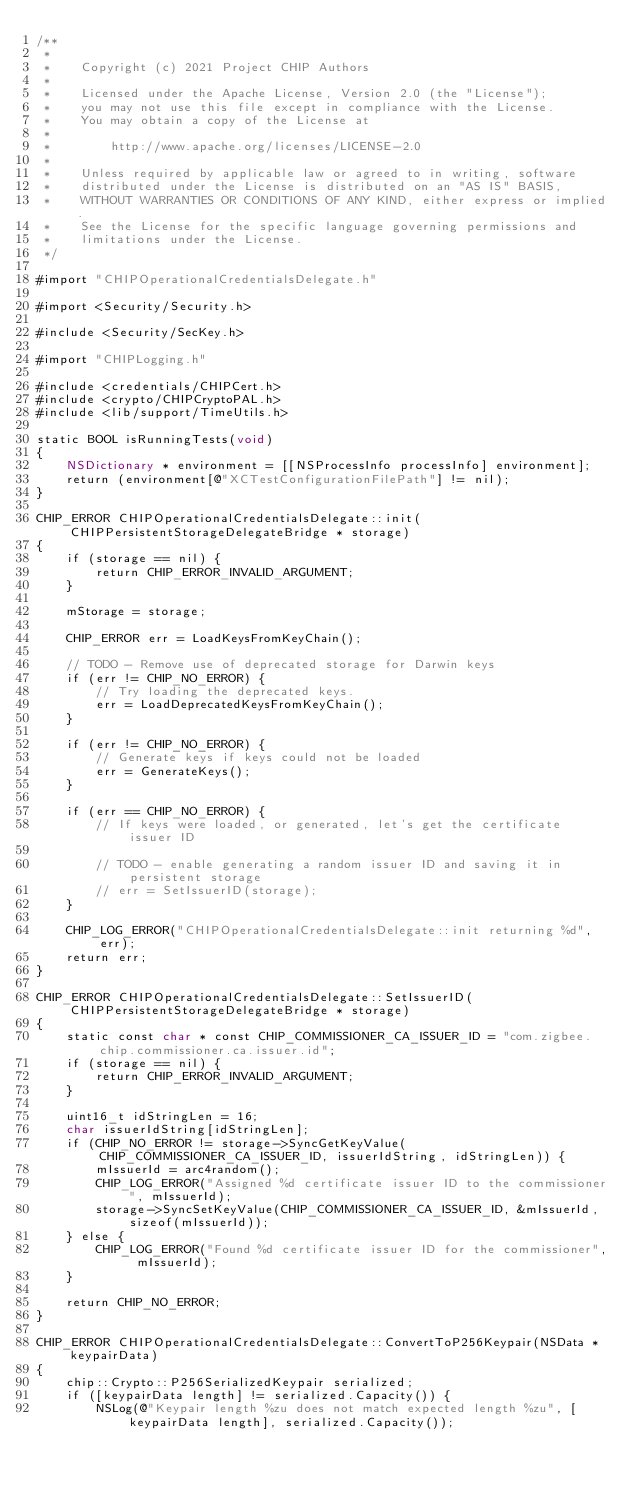Convert code to text. <code><loc_0><loc_0><loc_500><loc_500><_ObjectiveC_>/**
 *
 *    Copyright (c) 2021 Project CHIP Authors
 *
 *    Licensed under the Apache License, Version 2.0 (the "License");
 *    you may not use this file except in compliance with the License.
 *    You may obtain a copy of the License at
 *
 *        http://www.apache.org/licenses/LICENSE-2.0
 *
 *    Unless required by applicable law or agreed to in writing, software
 *    distributed under the License is distributed on an "AS IS" BASIS,
 *    WITHOUT WARRANTIES OR CONDITIONS OF ANY KIND, either express or implied.
 *    See the License for the specific language governing permissions and
 *    limitations under the License.
 */

#import "CHIPOperationalCredentialsDelegate.h"

#import <Security/Security.h>

#include <Security/SecKey.h>

#import "CHIPLogging.h"

#include <credentials/CHIPCert.h>
#include <crypto/CHIPCryptoPAL.h>
#include <lib/support/TimeUtils.h>

static BOOL isRunningTests(void)
{
    NSDictionary * environment = [[NSProcessInfo processInfo] environment];
    return (environment[@"XCTestConfigurationFilePath"] != nil);
}

CHIP_ERROR CHIPOperationalCredentialsDelegate::init(CHIPPersistentStorageDelegateBridge * storage)
{
    if (storage == nil) {
        return CHIP_ERROR_INVALID_ARGUMENT;
    }

    mStorage = storage;

    CHIP_ERROR err = LoadKeysFromKeyChain();

    // TODO - Remove use of deprecated storage for Darwin keys
    if (err != CHIP_NO_ERROR) {
        // Try loading the deprecated keys.
        err = LoadDeprecatedKeysFromKeyChain();
    }

    if (err != CHIP_NO_ERROR) {
        // Generate keys if keys could not be loaded
        err = GenerateKeys();
    }

    if (err == CHIP_NO_ERROR) {
        // If keys were loaded, or generated, let's get the certificate issuer ID

        // TODO - enable generating a random issuer ID and saving it in persistent storage
        // err = SetIssuerID(storage);
    }

    CHIP_LOG_ERROR("CHIPOperationalCredentialsDelegate::init returning %d", err);
    return err;
}

CHIP_ERROR CHIPOperationalCredentialsDelegate::SetIssuerID(CHIPPersistentStorageDelegateBridge * storage)
{
    static const char * const CHIP_COMMISSIONER_CA_ISSUER_ID = "com.zigbee.chip.commissioner.ca.issuer.id";
    if (storage == nil) {
        return CHIP_ERROR_INVALID_ARGUMENT;
    }

    uint16_t idStringLen = 16;
    char issuerIdString[idStringLen];
    if (CHIP_NO_ERROR != storage->SyncGetKeyValue(CHIP_COMMISSIONER_CA_ISSUER_ID, issuerIdString, idStringLen)) {
        mIssuerId = arc4random();
        CHIP_LOG_ERROR("Assigned %d certificate issuer ID to the commissioner", mIssuerId);
        storage->SyncSetKeyValue(CHIP_COMMISSIONER_CA_ISSUER_ID, &mIssuerId, sizeof(mIssuerId));
    } else {
        CHIP_LOG_ERROR("Found %d certificate issuer ID for the commissioner", mIssuerId);
    }

    return CHIP_NO_ERROR;
}

CHIP_ERROR CHIPOperationalCredentialsDelegate::ConvertToP256Keypair(NSData * keypairData)
{
    chip::Crypto::P256SerializedKeypair serialized;
    if ([keypairData length] != serialized.Capacity()) {
        NSLog(@"Keypair length %zu does not match expected length %zu", [keypairData length], serialized.Capacity());</code> 